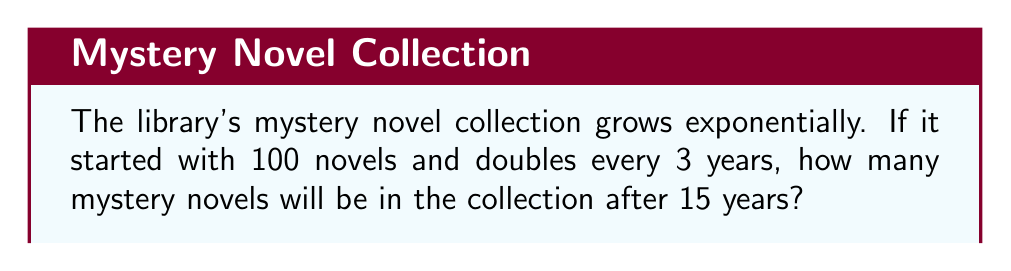Solve this math problem. Let's approach this step-by-step:

1) We start with the initial number of novels: $N_0 = 100$

2) The growth rate is doubling (×2) every 3 years. This means:
   Growth factor per 3-year period: $r = 2$

3) We need to find out how many 3-year periods are in 15 years:
   Number of periods: $t = 15 ÷ 3 = 5$

4) The exponential growth formula is:
   $N = N_0 \times r^t$

   Where:
   $N$ is the final number of novels
   $N_0$ is the initial number of novels
   $r$ is the growth factor
   $t$ is the number of time periods

5) Substituting our values:
   $N = 100 \times 2^5$

6) Calculate:
   $N = 100 \times 32 = 3200$

Therefore, after 15 years, there will be 3200 mystery novels in the collection.
Answer: 3200 novels 